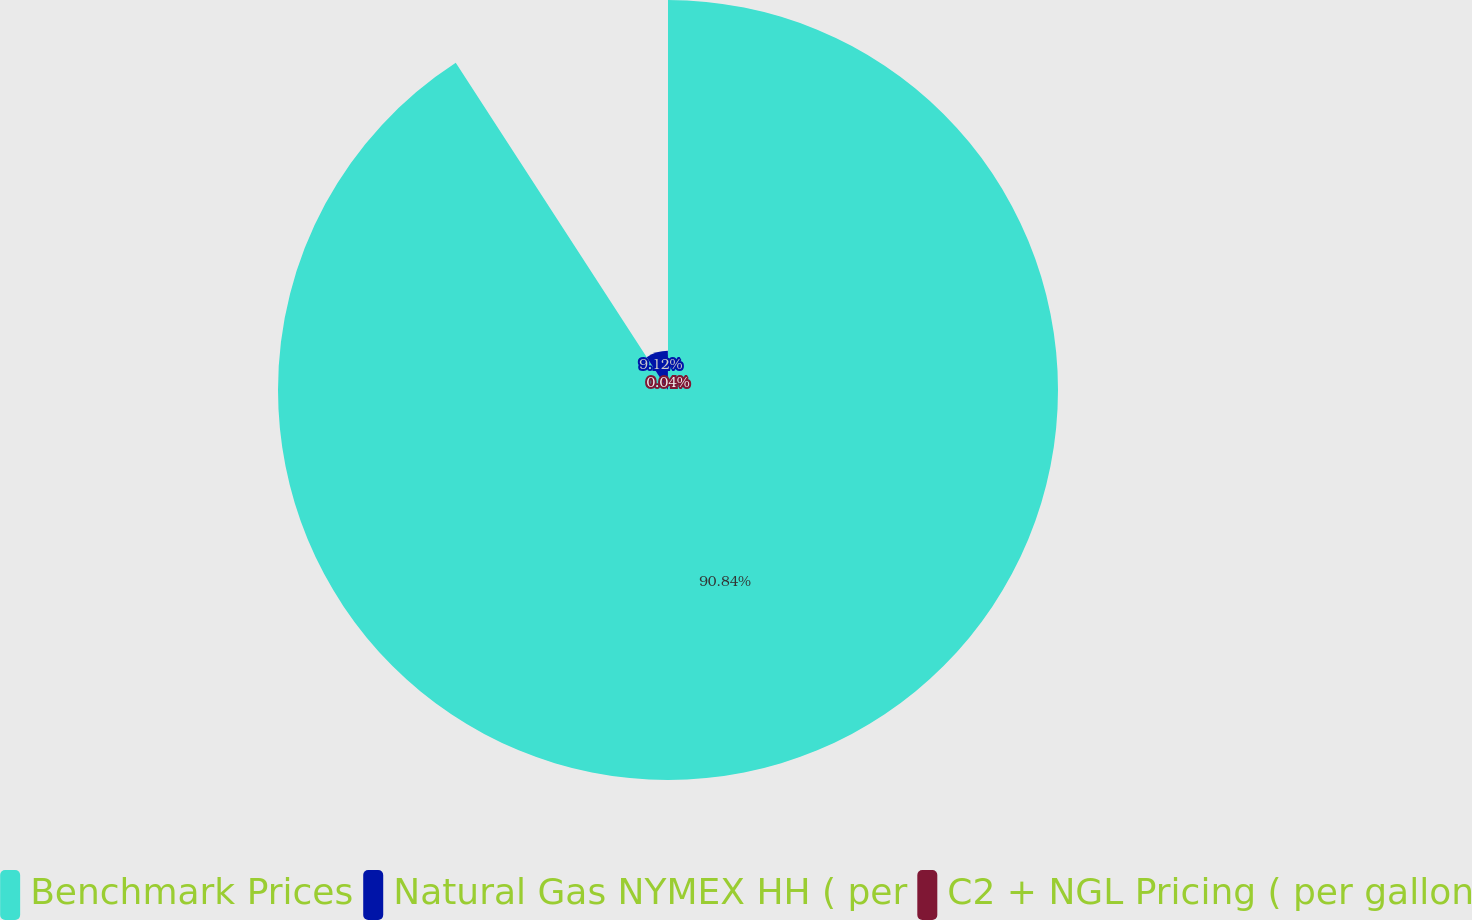Convert chart. <chart><loc_0><loc_0><loc_500><loc_500><pie_chart><fcel>Benchmark Prices<fcel>Natural Gas NYMEX HH ( per<fcel>C2 + NGL Pricing ( per gallon<nl><fcel>90.85%<fcel>9.12%<fcel>0.04%<nl></chart> 